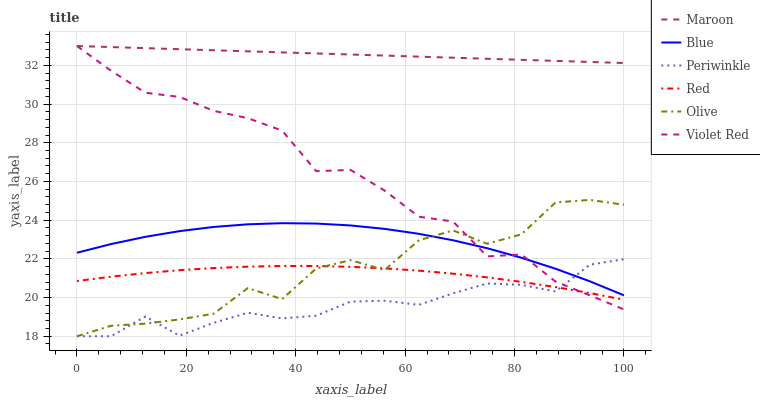Does Periwinkle have the minimum area under the curve?
Answer yes or no. Yes. Does Maroon have the maximum area under the curve?
Answer yes or no. Yes. Does Violet Red have the minimum area under the curve?
Answer yes or no. No. Does Violet Red have the maximum area under the curve?
Answer yes or no. No. Is Maroon the smoothest?
Answer yes or no. Yes. Is Olive the roughest?
Answer yes or no. Yes. Is Violet Red the smoothest?
Answer yes or no. No. Is Violet Red the roughest?
Answer yes or no. No. Does Periwinkle have the lowest value?
Answer yes or no. Yes. Does Violet Red have the lowest value?
Answer yes or no. No. Does Maroon have the highest value?
Answer yes or no. Yes. Does Periwinkle have the highest value?
Answer yes or no. No. Is Blue less than Maroon?
Answer yes or no. Yes. Is Blue greater than Red?
Answer yes or no. Yes. Does Periwinkle intersect Red?
Answer yes or no. Yes. Is Periwinkle less than Red?
Answer yes or no. No. Is Periwinkle greater than Red?
Answer yes or no. No. Does Blue intersect Maroon?
Answer yes or no. No. 